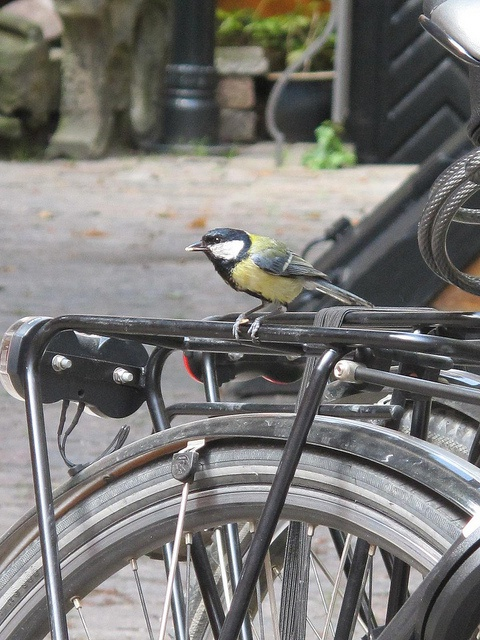Describe the objects in this image and their specific colors. I can see bicycle in black, gray, darkgray, and lightgray tones, bird in black, gray, darkgray, and tan tones, and potted plant in black and olive tones in this image. 